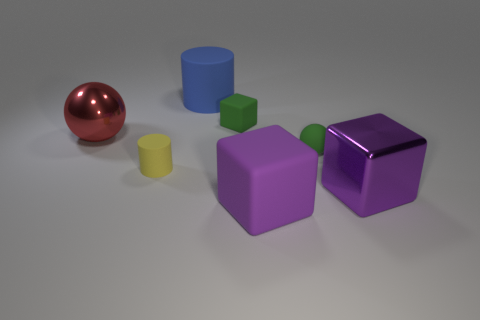Are there fewer small objects on the left side of the blue matte object than purple blocks right of the big purple matte object?
Offer a terse response. No. Does the green matte ball have the same size as the rubber cylinder that is in front of the big red metal object?
Make the answer very short. Yes. What number of green spheres have the same size as the red sphere?
Make the answer very short. 0. How many large objects are yellow things or brown matte balls?
Keep it short and to the point. 0. Are any cyan matte blocks visible?
Give a very brief answer. No. Is the number of rubber cubes left of the blue rubber object greater than the number of yellow cylinders that are in front of the purple metal object?
Give a very brief answer. No. There is a big thing behind the small green object behind the large metal sphere; what is its color?
Ensure brevity in your answer.  Blue. Is there a big metallic cube that has the same color as the large metal ball?
Offer a very short reply. No. There is a metallic thing that is right of the cylinder in front of the large blue object behind the big shiny sphere; how big is it?
Keep it short and to the point. Large. What is the shape of the big red object?
Provide a short and direct response. Sphere. 